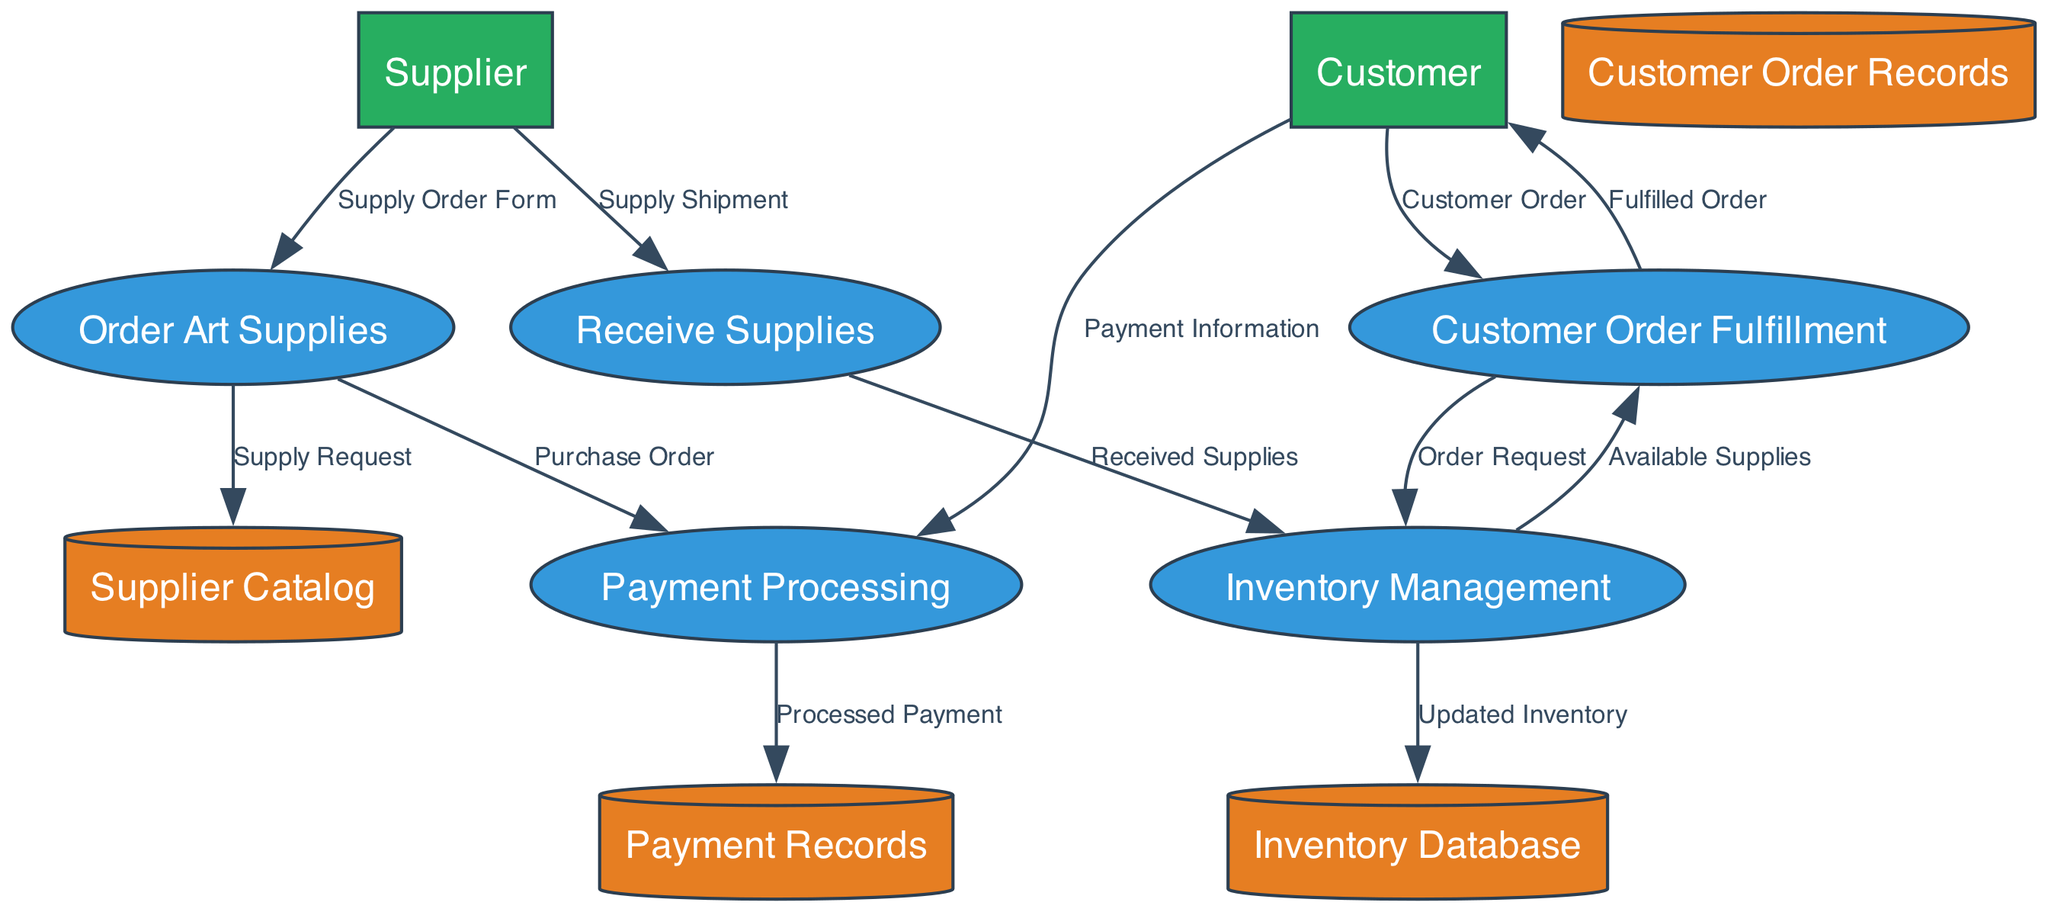What are the main processes in the diagram? The main processes are shown as numbered ellipses. They include: Order Art Supplies, Receive Supplies, Inventory Management, Payment Processing, and Customer Order Fulfillment.
Answer: Order Art Supplies, Receive Supplies, Inventory Management, Payment Processing, Customer Order Fulfillment How many data stores are present in the diagram? The diagram includes four data stores: Supplier Catalog, Inventory Database, Customer Order Records, and Payment Records. Each store is represented distinctly and contributes to the overall workflow.
Answer: Four What entity interacts with the "Receive Supplies" process? The "Receive Supplies" process receives data from the Supplier external entity, as indicated by the directed flow from Supplier to Receive Supplies labeled "Supply Shipment."
Answer: Supplier Which process sends "Available Supplies" to "Customer Order Fulfillment"? The Inventory Management process sends "Available Supplies" to Customer Order Fulfillment, as depicted by the connecting flow labeled with that content.
Answer: Inventory Management What data flow originates from the Customer to the Payment Processing process? The created data flow labeled "Payment Information" originates from the Customer and is directed towards the Payment Processing process, facilitating the payment aspect of the order.
Answer: Payment Information Describe the relationship between "Order Art Supplies" and "Payment Processing." Order Art Supplies sends a "Purchase Order" to the Payment Processing process, reflecting the necessary step of processing payment for the ordered supplies.
Answer: Purchase Order How many external entities are represented in the diagram? There are two external entities in the diagram: Supplier and Customer. Each external entity plays a crucial role in the overall supply chain management.
Answer: Two What data flows out from the "Payment Processing" process? The data flow labelled "Processed Payment" is sent to the Payment Records data store from Payment Processing, indicating successful payment transactions.
Answer: Processed Payment Which process leads to the update of the Inventory Database? The Inventory Management process updates the Inventory Database as indicated by the data flow labeled "Updated Inventory," reflecting the current inventory status post-supply reception.
Answer: Inventory Management 